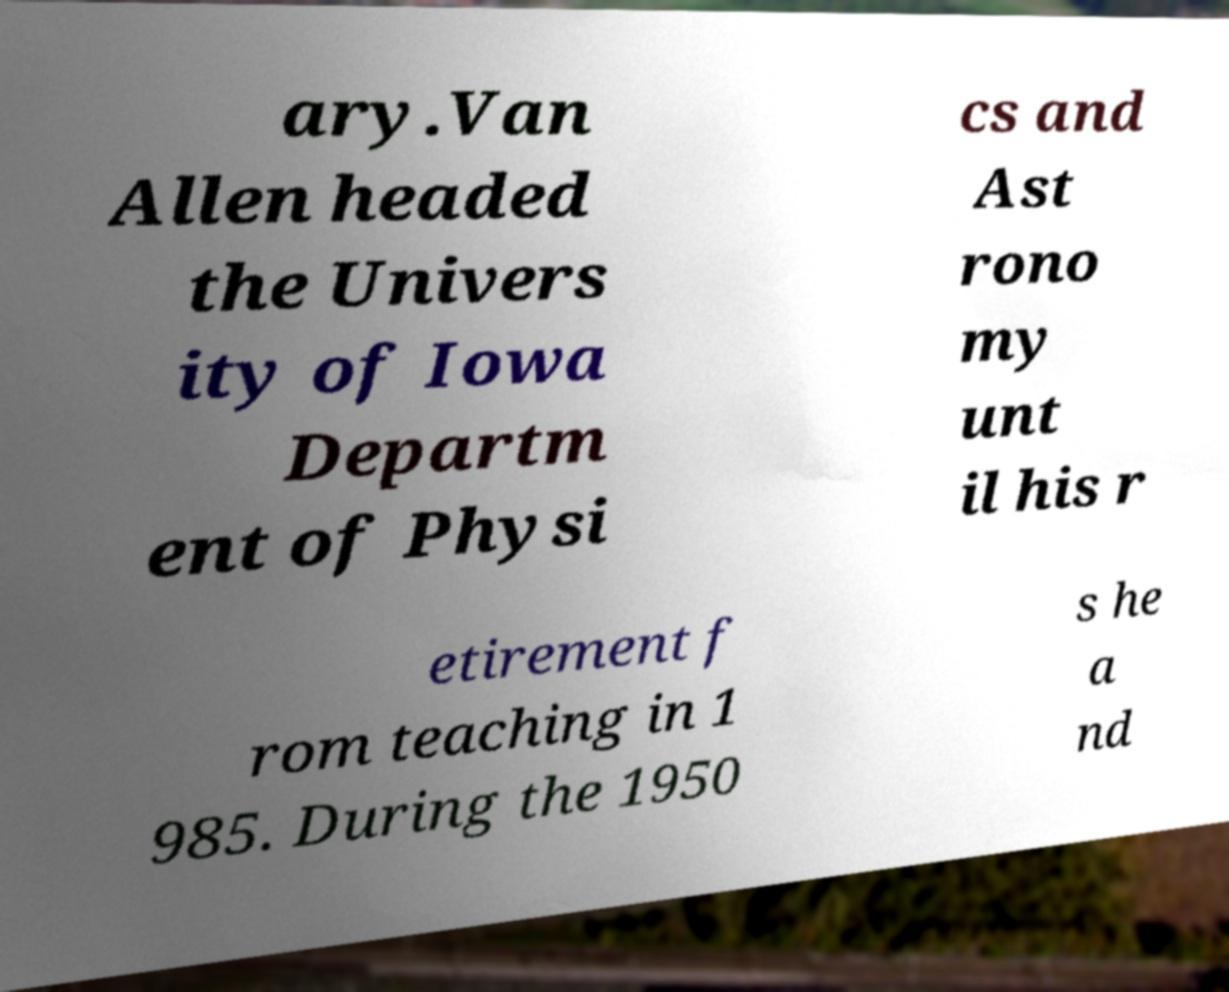I need the written content from this picture converted into text. Can you do that? ary.Van Allen headed the Univers ity of Iowa Departm ent of Physi cs and Ast rono my unt il his r etirement f rom teaching in 1 985. During the 1950 s he a nd 